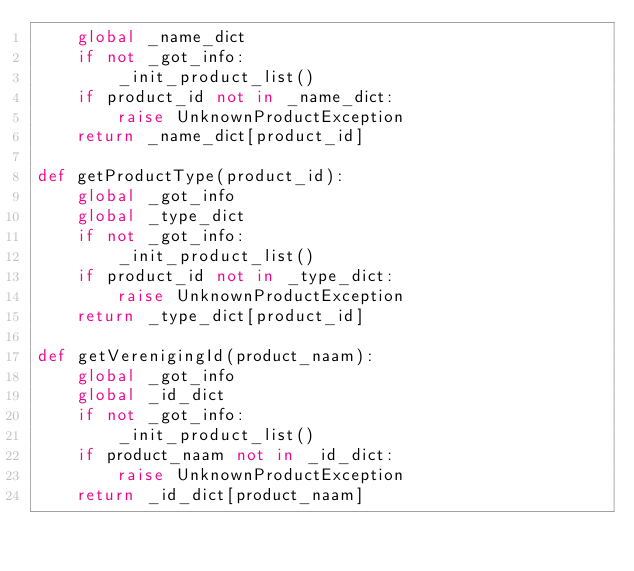<code> <loc_0><loc_0><loc_500><loc_500><_Python_>    global _name_dict
    if not _got_info:
        _init_product_list()
    if product_id not in _name_dict:
        raise UnknownProductException
    return _name_dict[product_id]

def getProductType(product_id):
    global _got_info
    global _type_dict
    if not _got_info:
        _init_product_list()
    if product_id not in _type_dict:
        raise UnknownProductException
    return _type_dict[product_id]

def getVerenigingId(product_naam):
    global _got_info
    global _id_dict
    if not _got_info:
        _init_product_list()
    if product_naam not in _id_dict:
        raise UnknownProductException
    return _id_dict[product_naam]
</code> 